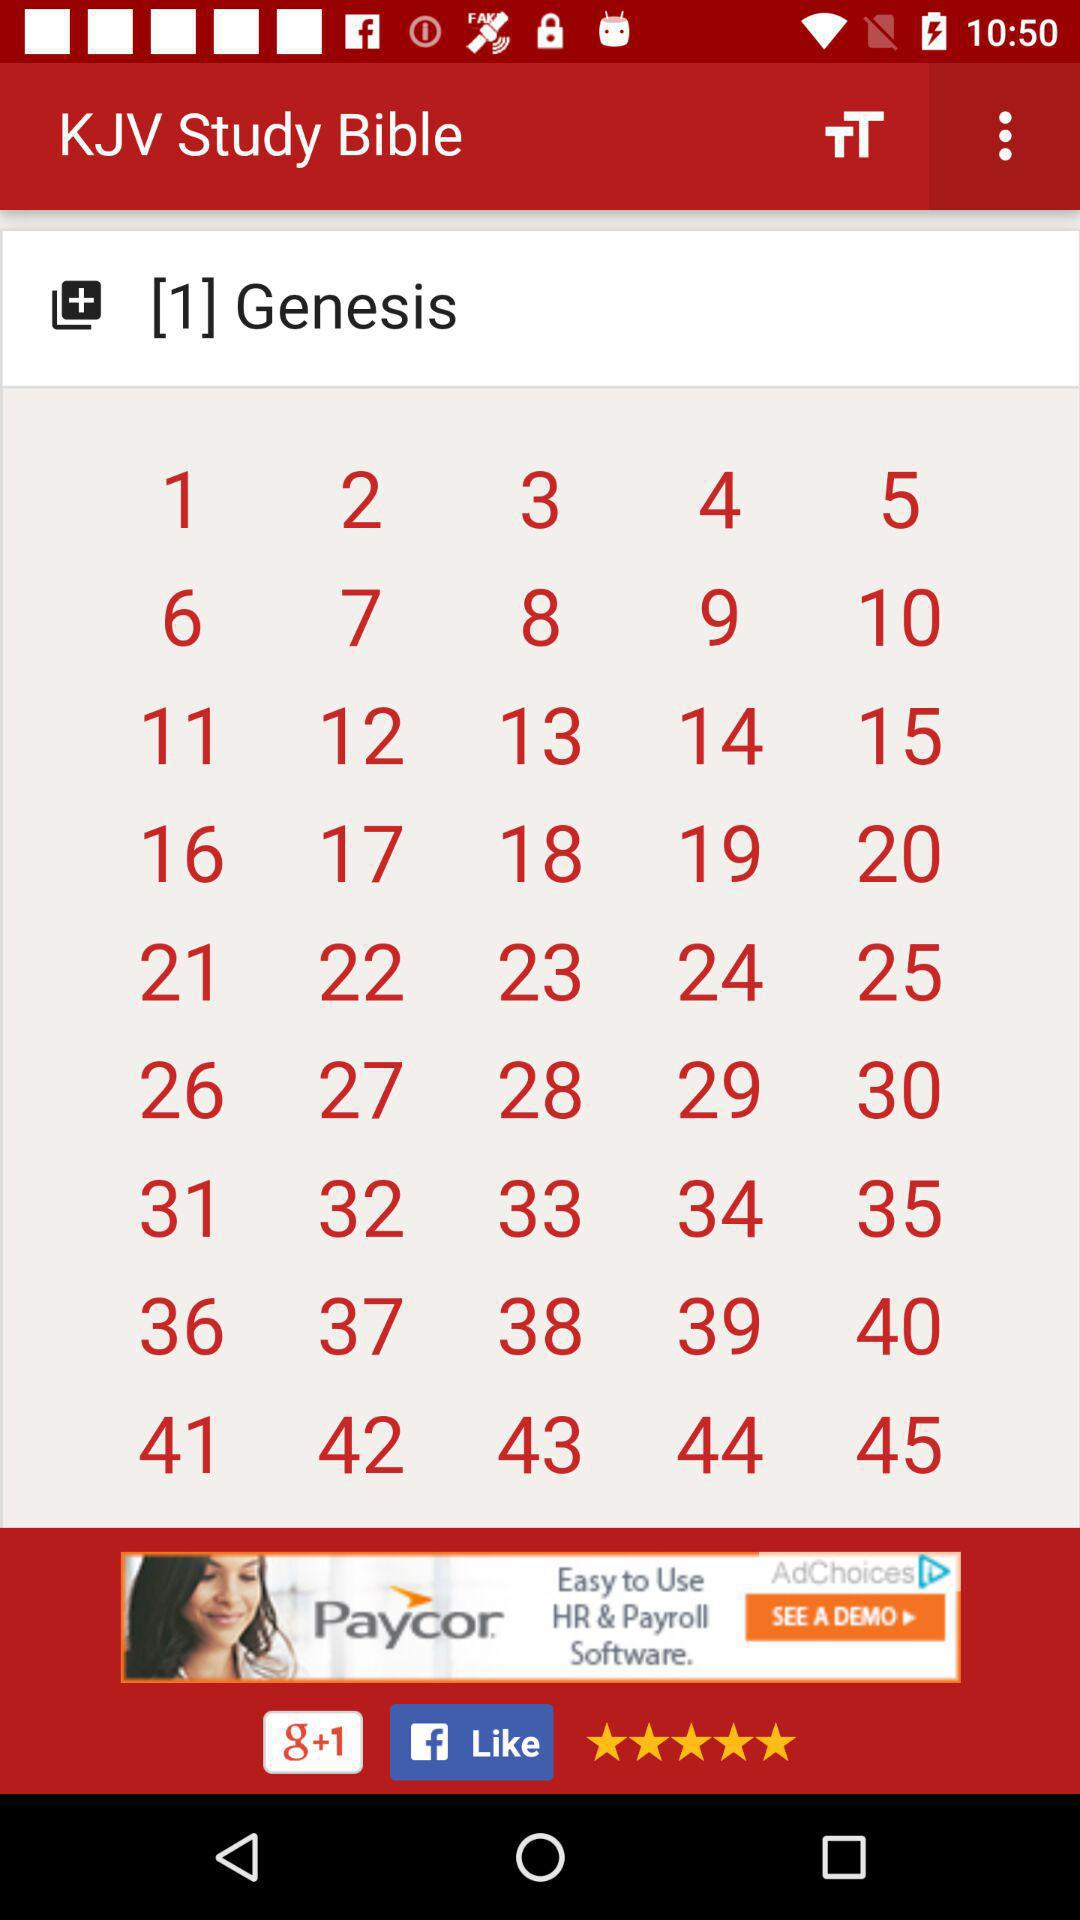What's the last Number of chapter of the " Genesis"?
When the provided information is insufficient, respond with <no answer>. <no answer> 